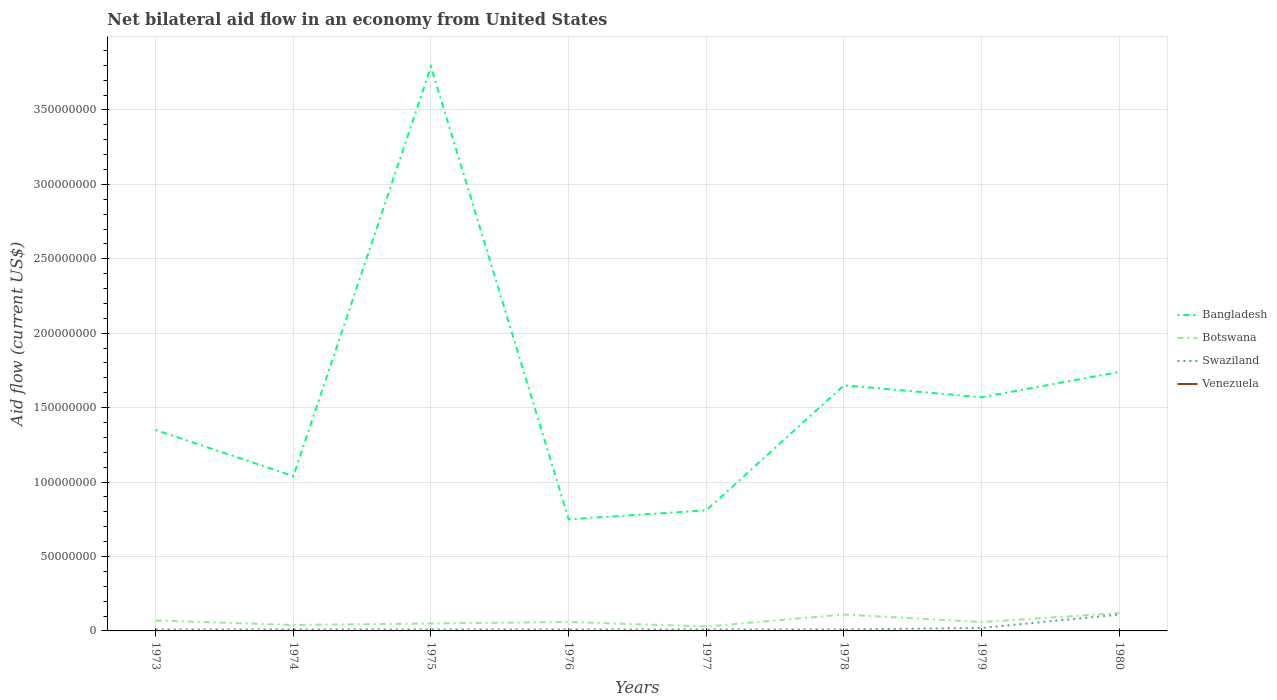How many different coloured lines are there?
Give a very brief answer. 3. Across all years, what is the maximum net bilateral aid flow in Bangladesh?
Your answer should be very brief. 7.50e+07. What is the total net bilateral aid flow in Bangladesh in the graph?
Offer a very short reply. 2.22e+08. What is the difference between the highest and the second highest net bilateral aid flow in Botswana?
Offer a terse response. 9.00e+06. How many years are there in the graph?
Offer a terse response. 8. What is the difference between two consecutive major ticks on the Y-axis?
Your answer should be very brief. 5.00e+07. Are the values on the major ticks of Y-axis written in scientific E-notation?
Your response must be concise. No. Where does the legend appear in the graph?
Your answer should be compact. Center right. How many legend labels are there?
Keep it short and to the point. 4. What is the title of the graph?
Give a very brief answer. Net bilateral aid flow in an economy from United States. What is the label or title of the X-axis?
Offer a very short reply. Years. What is the Aid flow (current US$) of Bangladesh in 1973?
Make the answer very short. 1.35e+08. What is the Aid flow (current US$) of Botswana in 1973?
Your response must be concise. 7.00e+06. What is the Aid flow (current US$) in Bangladesh in 1974?
Your response must be concise. 1.04e+08. What is the Aid flow (current US$) of Botswana in 1974?
Offer a very short reply. 4.00e+06. What is the Aid flow (current US$) of Bangladesh in 1975?
Your answer should be compact. 3.79e+08. What is the Aid flow (current US$) in Botswana in 1975?
Ensure brevity in your answer.  5.00e+06. What is the Aid flow (current US$) of Swaziland in 1975?
Your answer should be compact. 1.00e+06. What is the Aid flow (current US$) in Venezuela in 1975?
Ensure brevity in your answer.  0. What is the Aid flow (current US$) of Bangladesh in 1976?
Ensure brevity in your answer.  7.50e+07. What is the Aid flow (current US$) in Botswana in 1976?
Keep it short and to the point. 6.00e+06. What is the Aid flow (current US$) in Swaziland in 1976?
Your answer should be compact. 1.00e+06. What is the Aid flow (current US$) of Venezuela in 1976?
Provide a succinct answer. 0. What is the Aid flow (current US$) in Bangladesh in 1977?
Offer a very short reply. 8.10e+07. What is the Aid flow (current US$) in Swaziland in 1977?
Give a very brief answer. 1.00e+06. What is the Aid flow (current US$) in Venezuela in 1977?
Ensure brevity in your answer.  0. What is the Aid flow (current US$) of Bangladesh in 1978?
Ensure brevity in your answer.  1.65e+08. What is the Aid flow (current US$) of Botswana in 1978?
Provide a succinct answer. 1.10e+07. What is the Aid flow (current US$) in Bangladesh in 1979?
Your answer should be very brief. 1.57e+08. What is the Aid flow (current US$) in Swaziland in 1979?
Keep it short and to the point. 2.00e+06. What is the Aid flow (current US$) of Venezuela in 1979?
Ensure brevity in your answer.  0. What is the Aid flow (current US$) in Bangladesh in 1980?
Make the answer very short. 1.74e+08. What is the Aid flow (current US$) in Botswana in 1980?
Provide a succinct answer. 1.20e+07. What is the Aid flow (current US$) in Swaziland in 1980?
Provide a succinct answer. 1.10e+07. What is the Aid flow (current US$) in Venezuela in 1980?
Keep it short and to the point. 0. Across all years, what is the maximum Aid flow (current US$) in Bangladesh?
Your response must be concise. 3.79e+08. Across all years, what is the maximum Aid flow (current US$) in Swaziland?
Keep it short and to the point. 1.10e+07. Across all years, what is the minimum Aid flow (current US$) in Bangladesh?
Provide a short and direct response. 7.50e+07. Across all years, what is the minimum Aid flow (current US$) of Botswana?
Provide a short and direct response. 3.00e+06. What is the total Aid flow (current US$) in Bangladesh in the graph?
Offer a terse response. 1.27e+09. What is the total Aid flow (current US$) of Botswana in the graph?
Ensure brevity in your answer.  5.40e+07. What is the total Aid flow (current US$) in Swaziland in the graph?
Provide a succinct answer. 1.90e+07. What is the total Aid flow (current US$) in Venezuela in the graph?
Offer a very short reply. 0. What is the difference between the Aid flow (current US$) of Bangladesh in 1973 and that in 1974?
Your answer should be very brief. 3.10e+07. What is the difference between the Aid flow (current US$) of Swaziland in 1973 and that in 1974?
Ensure brevity in your answer.  0. What is the difference between the Aid flow (current US$) of Bangladesh in 1973 and that in 1975?
Give a very brief answer. -2.44e+08. What is the difference between the Aid flow (current US$) in Botswana in 1973 and that in 1975?
Offer a very short reply. 2.00e+06. What is the difference between the Aid flow (current US$) in Swaziland in 1973 and that in 1975?
Your answer should be very brief. 0. What is the difference between the Aid flow (current US$) in Bangladesh in 1973 and that in 1976?
Your response must be concise. 6.00e+07. What is the difference between the Aid flow (current US$) in Botswana in 1973 and that in 1976?
Offer a terse response. 1.00e+06. What is the difference between the Aid flow (current US$) of Swaziland in 1973 and that in 1976?
Provide a succinct answer. 0. What is the difference between the Aid flow (current US$) in Bangladesh in 1973 and that in 1977?
Keep it short and to the point. 5.40e+07. What is the difference between the Aid flow (current US$) of Botswana in 1973 and that in 1977?
Keep it short and to the point. 4.00e+06. What is the difference between the Aid flow (current US$) in Swaziland in 1973 and that in 1977?
Offer a very short reply. 0. What is the difference between the Aid flow (current US$) in Bangladesh in 1973 and that in 1978?
Offer a very short reply. -3.00e+07. What is the difference between the Aid flow (current US$) in Botswana in 1973 and that in 1978?
Your response must be concise. -4.00e+06. What is the difference between the Aid flow (current US$) in Swaziland in 1973 and that in 1978?
Ensure brevity in your answer.  0. What is the difference between the Aid flow (current US$) of Bangladesh in 1973 and that in 1979?
Keep it short and to the point. -2.20e+07. What is the difference between the Aid flow (current US$) in Bangladesh in 1973 and that in 1980?
Give a very brief answer. -3.90e+07. What is the difference between the Aid flow (current US$) in Botswana in 1973 and that in 1980?
Provide a succinct answer. -5.00e+06. What is the difference between the Aid flow (current US$) in Swaziland in 1973 and that in 1980?
Ensure brevity in your answer.  -1.00e+07. What is the difference between the Aid flow (current US$) of Bangladesh in 1974 and that in 1975?
Your answer should be very brief. -2.75e+08. What is the difference between the Aid flow (current US$) in Botswana in 1974 and that in 1975?
Your response must be concise. -1.00e+06. What is the difference between the Aid flow (current US$) of Swaziland in 1974 and that in 1975?
Offer a terse response. 0. What is the difference between the Aid flow (current US$) in Bangladesh in 1974 and that in 1976?
Make the answer very short. 2.90e+07. What is the difference between the Aid flow (current US$) in Botswana in 1974 and that in 1976?
Keep it short and to the point. -2.00e+06. What is the difference between the Aid flow (current US$) of Swaziland in 1974 and that in 1976?
Offer a very short reply. 0. What is the difference between the Aid flow (current US$) of Bangladesh in 1974 and that in 1977?
Your answer should be very brief. 2.30e+07. What is the difference between the Aid flow (current US$) in Swaziland in 1974 and that in 1977?
Keep it short and to the point. 0. What is the difference between the Aid flow (current US$) in Bangladesh in 1974 and that in 1978?
Offer a very short reply. -6.10e+07. What is the difference between the Aid flow (current US$) in Botswana in 1974 and that in 1978?
Your answer should be compact. -7.00e+06. What is the difference between the Aid flow (current US$) of Swaziland in 1974 and that in 1978?
Make the answer very short. 0. What is the difference between the Aid flow (current US$) in Bangladesh in 1974 and that in 1979?
Offer a very short reply. -5.30e+07. What is the difference between the Aid flow (current US$) in Botswana in 1974 and that in 1979?
Offer a terse response. -2.00e+06. What is the difference between the Aid flow (current US$) of Swaziland in 1974 and that in 1979?
Provide a succinct answer. -1.00e+06. What is the difference between the Aid flow (current US$) in Bangladesh in 1974 and that in 1980?
Offer a terse response. -7.00e+07. What is the difference between the Aid flow (current US$) in Botswana in 1974 and that in 1980?
Ensure brevity in your answer.  -8.00e+06. What is the difference between the Aid flow (current US$) of Swaziland in 1974 and that in 1980?
Offer a terse response. -1.00e+07. What is the difference between the Aid flow (current US$) of Bangladesh in 1975 and that in 1976?
Ensure brevity in your answer.  3.04e+08. What is the difference between the Aid flow (current US$) of Swaziland in 1975 and that in 1976?
Your answer should be compact. 0. What is the difference between the Aid flow (current US$) in Bangladesh in 1975 and that in 1977?
Offer a terse response. 2.98e+08. What is the difference between the Aid flow (current US$) of Botswana in 1975 and that in 1977?
Ensure brevity in your answer.  2.00e+06. What is the difference between the Aid flow (current US$) in Bangladesh in 1975 and that in 1978?
Provide a short and direct response. 2.14e+08. What is the difference between the Aid flow (current US$) in Botswana in 1975 and that in 1978?
Your response must be concise. -6.00e+06. What is the difference between the Aid flow (current US$) of Swaziland in 1975 and that in 1978?
Your response must be concise. 0. What is the difference between the Aid flow (current US$) of Bangladesh in 1975 and that in 1979?
Ensure brevity in your answer.  2.22e+08. What is the difference between the Aid flow (current US$) in Botswana in 1975 and that in 1979?
Provide a succinct answer. -1.00e+06. What is the difference between the Aid flow (current US$) of Bangladesh in 1975 and that in 1980?
Offer a terse response. 2.05e+08. What is the difference between the Aid flow (current US$) of Botswana in 1975 and that in 1980?
Give a very brief answer. -7.00e+06. What is the difference between the Aid flow (current US$) of Swaziland in 1975 and that in 1980?
Your answer should be very brief. -1.00e+07. What is the difference between the Aid flow (current US$) in Bangladesh in 1976 and that in 1977?
Give a very brief answer. -6.00e+06. What is the difference between the Aid flow (current US$) of Botswana in 1976 and that in 1977?
Your response must be concise. 3.00e+06. What is the difference between the Aid flow (current US$) in Bangladesh in 1976 and that in 1978?
Give a very brief answer. -9.00e+07. What is the difference between the Aid flow (current US$) of Botswana in 1976 and that in 1978?
Provide a short and direct response. -5.00e+06. What is the difference between the Aid flow (current US$) of Swaziland in 1976 and that in 1978?
Your answer should be very brief. 0. What is the difference between the Aid flow (current US$) of Bangladesh in 1976 and that in 1979?
Ensure brevity in your answer.  -8.20e+07. What is the difference between the Aid flow (current US$) of Bangladesh in 1976 and that in 1980?
Give a very brief answer. -9.90e+07. What is the difference between the Aid flow (current US$) of Botswana in 1976 and that in 1980?
Offer a terse response. -6.00e+06. What is the difference between the Aid flow (current US$) in Swaziland in 1976 and that in 1980?
Make the answer very short. -1.00e+07. What is the difference between the Aid flow (current US$) in Bangladesh in 1977 and that in 1978?
Give a very brief answer. -8.40e+07. What is the difference between the Aid flow (current US$) of Botswana in 1977 and that in 1978?
Keep it short and to the point. -8.00e+06. What is the difference between the Aid flow (current US$) of Bangladesh in 1977 and that in 1979?
Offer a terse response. -7.60e+07. What is the difference between the Aid flow (current US$) in Swaziland in 1977 and that in 1979?
Offer a very short reply. -1.00e+06. What is the difference between the Aid flow (current US$) in Bangladesh in 1977 and that in 1980?
Provide a succinct answer. -9.30e+07. What is the difference between the Aid flow (current US$) of Botswana in 1977 and that in 1980?
Make the answer very short. -9.00e+06. What is the difference between the Aid flow (current US$) in Swaziland in 1977 and that in 1980?
Your response must be concise. -1.00e+07. What is the difference between the Aid flow (current US$) of Bangladesh in 1978 and that in 1979?
Make the answer very short. 8.00e+06. What is the difference between the Aid flow (current US$) of Swaziland in 1978 and that in 1979?
Offer a very short reply. -1.00e+06. What is the difference between the Aid flow (current US$) of Bangladesh in 1978 and that in 1980?
Provide a short and direct response. -9.00e+06. What is the difference between the Aid flow (current US$) of Swaziland in 1978 and that in 1980?
Offer a terse response. -1.00e+07. What is the difference between the Aid flow (current US$) of Bangladesh in 1979 and that in 1980?
Ensure brevity in your answer.  -1.70e+07. What is the difference between the Aid flow (current US$) in Botswana in 1979 and that in 1980?
Offer a very short reply. -6.00e+06. What is the difference between the Aid flow (current US$) in Swaziland in 1979 and that in 1980?
Give a very brief answer. -9.00e+06. What is the difference between the Aid flow (current US$) in Bangladesh in 1973 and the Aid flow (current US$) in Botswana in 1974?
Provide a short and direct response. 1.31e+08. What is the difference between the Aid flow (current US$) in Bangladesh in 1973 and the Aid flow (current US$) in Swaziland in 1974?
Provide a succinct answer. 1.34e+08. What is the difference between the Aid flow (current US$) in Botswana in 1973 and the Aid flow (current US$) in Swaziland in 1974?
Provide a short and direct response. 6.00e+06. What is the difference between the Aid flow (current US$) of Bangladesh in 1973 and the Aid flow (current US$) of Botswana in 1975?
Make the answer very short. 1.30e+08. What is the difference between the Aid flow (current US$) of Bangladesh in 1973 and the Aid flow (current US$) of Swaziland in 1975?
Your answer should be very brief. 1.34e+08. What is the difference between the Aid flow (current US$) of Botswana in 1973 and the Aid flow (current US$) of Swaziland in 1975?
Offer a very short reply. 6.00e+06. What is the difference between the Aid flow (current US$) of Bangladesh in 1973 and the Aid flow (current US$) of Botswana in 1976?
Give a very brief answer. 1.29e+08. What is the difference between the Aid flow (current US$) of Bangladesh in 1973 and the Aid flow (current US$) of Swaziland in 1976?
Offer a terse response. 1.34e+08. What is the difference between the Aid flow (current US$) of Botswana in 1973 and the Aid flow (current US$) of Swaziland in 1976?
Provide a succinct answer. 6.00e+06. What is the difference between the Aid flow (current US$) in Bangladesh in 1973 and the Aid flow (current US$) in Botswana in 1977?
Offer a terse response. 1.32e+08. What is the difference between the Aid flow (current US$) of Bangladesh in 1973 and the Aid flow (current US$) of Swaziland in 1977?
Provide a succinct answer. 1.34e+08. What is the difference between the Aid flow (current US$) in Bangladesh in 1973 and the Aid flow (current US$) in Botswana in 1978?
Give a very brief answer. 1.24e+08. What is the difference between the Aid flow (current US$) in Bangladesh in 1973 and the Aid flow (current US$) in Swaziland in 1978?
Provide a short and direct response. 1.34e+08. What is the difference between the Aid flow (current US$) of Bangladesh in 1973 and the Aid flow (current US$) of Botswana in 1979?
Your response must be concise. 1.29e+08. What is the difference between the Aid flow (current US$) in Bangladesh in 1973 and the Aid flow (current US$) in Swaziland in 1979?
Offer a terse response. 1.33e+08. What is the difference between the Aid flow (current US$) in Botswana in 1973 and the Aid flow (current US$) in Swaziland in 1979?
Give a very brief answer. 5.00e+06. What is the difference between the Aid flow (current US$) of Bangladesh in 1973 and the Aid flow (current US$) of Botswana in 1980?
Your answer should be compact. 1.23e+08. What is the difference between the Aid flow (current US$) of Bangladesh in 1973 and the Aid flow (current US$) of Swaziland in 1980?
Your response must be concise. 1.24e+08. What is the difference between the Aid flow (current US$) of Botswana in 1973 and the Aid flow (current US$) of Swaziland in 1980?
Offer a terse response. -4.00e+06. What is the difference between the Aid flow (current US$) in Bangladesh in 1974 and the Aid flow (current US$) in Botswana in 1975?
Give a very brief answer. 9.90e+07. What is the difference between the Aid flow (current US$) in Bangladesh in 1974 and the Aid flow (current US$) in Swaziland in 1975?
Your answer should be compact. 1.03e+08. What is the difference between the Aid flow (current US$) of Botswana in 1974 and the Aid flow (current US$) of Swaziland in 1975?
Give a very brief answer. 3.00e+06. What is the difference between the Aid flow (current US$) of Bangladesh in 1974 and the Aid flow (current US$) of Botswana in 1976?
Keep it short and to the point. 9.80e+07. What is the difference between the Aid flow (current US$) in Bangladesh in 1974 and the Aid flow (current US$) in Swaziland in 1976?
Provide a succinct answer. 1.03e+08. What is the difference between the Aid flow (current US$) of Botswana in 1974 and the Aid flow (current US$) of Swaziland in 1976?
Provide a short and direct response. 3.00e+06. What is the difference between the Aid flow (current US$) of Bangladesh in 1974 and the Aid flow (current US$) of Botswana in 1977?
Give a very brief answer. 1.01e+08. What is the difference between the Aid flow (current US$) of Bangladesh in 1974 and the Aid flow (current US$) of Swaziland in 1977?
Offer a very short reply. 1.03e+08. What is the difference between the Aid flow (current US$) in Bangladesh in 1974 and the Aid flow (current US$) in Botswana in 1978?
Your answer should be very brief. 9.30e+07. What is the difference between the Aid flow (current US$) of Bangladesh in 1974 and the Aid flow (current US$) of Swaziland in 1978?
Your answer should be compact. 1.03e+08. What is the difference between the Aid flow (current US$) in Bangladesh in 1974 and the Aid flow (current US$) in Botswana in 1979?
Offer a terse response. 9.80e+07. What is the difference between the Aid flow (current US$) of Bangladesh in 1974 and the Aid flow (current US$) of Swaziland in 1979?
Your answer should be very brief. 1.02e+08. What is the difference between the Aid flow (current US$) in Bangladesh in 1974 and the Aid flow (current US$) in Botswana in 1980?
Keep it short and to the point. 9.20e+07. What is the difference between the Aid flow (current US$) of Bangladesh in 1974 and the Aid flow (current US$) of Swaziland in 1980?
Ensure brevity in your answer.  9.30e+07. What is the difference between the Aid flow (current US$) in Botswana in 1974 and the Aid flow (current US$) in Swaziland in 1980?
Give a very brief answer. -7.00e+06. What is the difference between the Aid flow (current US$) in Bangladesh in 1975 and the Aid flow (current US$) in Botswana in 1976?
Offer a terse response. 3.73e+08. What is the difference between the Aid flow (current US$) in Bangladesh in 1975 and the Aid flow (current US$) in Swaziland in 1976?
Keep it short and to the point. 3.78e+08. What is the difference between the Aid flow (current US$) in Botswana in 1975 and the Aid flow (current US$) in Swaziland in 1976?
Provide a succinct answer. 4.00e+06. What is the difference between the Aid flow (current US$) of Bangladesh in 1975 and the Aid flow (current US$) of Botswana in 1977?
Keep it short and to the point. 3.76e+08. What is the difference between the Aid flow (current US$) in Bangladesh in 1975 and the Aid flow (current US$) in Swaziland in 1977?
Make the answer very short. 3.78e+08. What is the difference between the Aid flow (current US$) in Botswana in 1975 and the Aid flow (current US$) in Swaziland in 1977?
Provide a succinct answer. 4.00e+06. What is the difference between the Aid flow (current US$) in Bangladesh in 1975 and the Aid flow (current US$) in Botswana in 1978?
Ensure brevity in your answer.  3.68e+08. What is the difference between the Aid flow (current US$) of Bangladesh in 1975 and the Aid flow (current US$) of Swaziland in 1978?
Ensure brevity in your answer.  3.78e+08. What is the difference between the Aid flow (current US$) in Botswana in 1975 and the Aid flow (current US$) in Swaziland in 1978?
Make the answer very short. 4.00e+06. What is the difference between the Aid flow (current US$) of Bangladesh in 1975 and the Aid flow (current US$) of Botswana in 1979?
Make the answer very short. 3.73e+08. What is the difference between the Aid flow (current US$) in Bangladesh in 1975 and the Aid flow (current US$) in Swaziland in 1979?
Offer a terse response. 3.77e+08. What is the difference between the Aid flow (current US$) in Botswana in 1975 and the Aid flow (current US$) in Swaziland in 1979?
Offer a terse response. 3.00e+06. What is the difference between the Aid flow (current US$) in Bangladesh in 1975 and the Aid flow (current US$) in Botswana in 1980?
Your answer should be compact. 3.67e+08. What is the difference between the Aid flow (current US$) in Bangladesh in 1975 and the Aid flow (current US$) in Swaziland in 1980?
Your answer should be compact. 3.68e+08. What is the difference between the Aid flow (current US$) of Botswana in 1975 and the Aid flow (current US$) of Swaziland in 1980?
Your response must be concise. -6.00e+06. What is the difference between the Aid flow (current US$) of Bangladesh in 1976 and the Aid flow (current US$) of Botswana in 1977?
Provide a succinct answer. 7.20e+07. What is the difference between the Aid flow (current US$) of Bangladesh in 1976 and the Aid flow (current US$) of Swaziland in 1977?
Make the answer very short. 7.40e+07. What is the difference between the Aid flow (current US$) of Botswana in 1976 and the Aid flow (current US$) of Swaziland in 1977?
Your answer should be compact. 5.00e+06. What is the difference between the Aid flow (current US$) in Bangladesh in 1976 and the Aid flow (current US$) in Botswana in 1978?
Give a very brief answer. 6.40e+07. What is the difference between the Aid flow (current US$) in Bangladesh in 1976 and the Aid flow (current US$) in Swaziland in 1978?
Give a very brief answer. 7.40e+07. What is the difference between the Aid flow (current US$) in Botswana in 1976 and the Aid flow (current US$) in Swaziland in 1978?
Your answer should be very brief. 5.00e+06. What is the difference between the Aid flow (current US$) in Bangladesh in 1976 and the Aid flow (current US$) in Botswana in 1979?
Make the answer very short. 6.90e+07. What is the difference between the Aid flow (current US$) of Bangladesh in 1976 and the Aid flow (current US$) of Swaziland in 1979?
Give a very brief answer. 7.30e+07. What is the difference between the Aid flow (current US$) in Botswana in 1976 and the Aid flow (current US$) in Swaziland in 1979?
Offer a terse response. 4.00e+06. What is the difference between the Aid flow (current US$) in Bangladesh in 1976 and the Aid flow (current US$) in Botswana in 1980?
Offer a terse response. 6.30e+07. What is the difference between the Aid flow (current US$) of Bangladesh in 1976 and the Aid flow (current US$) of Swaziland in 1980?
Your response must be concise. 6.40e+07. What is the difference between the Aid flow (current US$) in Botswana in 1976 and the Aid flow (current US$) in Swaziland in 1980?
Your answer should be compact. -5.00e+06. What is the difference between the Aid flow (current US$) in Bangladesh in 1977 and the Aid flow (current US$) in Botswana in 1978?
Make the answer very short. 7.00e+07. What is the difference between the Aid flow (current US$) of Bangladesh in 1977 and the Aid flow (current US$) of Swaziland in 1978?
Keep it short and to the point. 8.00e+07. What is the difference between the Aid flow (current US$) in Bangladesh in 1977 and the Aid flow (current US$) in Botswana in 1979?
Your answer should be very brief. 7.50e+07. What is the difference between the Aid flow (current US$) of Bangladesh in 1977 and the Aid flow (current US$) of Swaziland in 1979?
Ensure brevity in your answer.  7.90e+07. What is the difference between the Aid flow (current US$) in Botswana in 1977 and the Aid flow (current US$) in Swaziland in 1979?
Provide a short and direct response. 1.00e+06. What is the difference between the Aid flow (current US$) of Bangladesh in 1977 and the Aid flow (current US$) of Botswana in 1980?
Make the answer very short. 6.90e+07. What is the difference between the Aid flow (current US$) in Bangladesh in 1977 and the Aid flow (current US$) in Swaziland in 1980?
Keep it short and to the point. 7.00e+07. What is the difference between the Aid flow (current US$) in Botswana in 1977 and the Aid flow (current US$) in Swaziland in 1980?
Your answer should be compact. -8.00e+06. What is the difference between the Aid flow (current US$) of Bangladesh in 1978 and the Aid flow (current US$) of Botswana in 1979?
Your answer should be compact. 1.59e+08. What is the difference between the Aid flow (current US$) of Bangladesh in 1978 and the Aid flow (current US$) of Swaziland in 1979?
Offer a terse response. 1.63e+08. What is the difference between the Aid flow (current US$) of Botswana in 1978 and the Aid flow (current US$) of Swaziland in 1979?
Your response must be concise. 9.00e+06. What is the difference between the Aid flow (current US$) of Bangladesh in 1978 and the Aid flow (current US$) of Botswana in 1980?
Keep it short and to the point. 1.53e+08. What is the difference between the Aid flow (current US$) in Bangladesh in 1978 and the Aid flow (current US$) in Swaziland in 1980?
Give a very brief answer. 1.54e+08. What is the difference between the Aid flow (current US$) of Bangladesh in 1979 and the Aid flow (current US$) of Botswana in 1980?
Your answer should be very brief. 1.45e+08. What is the difference between the Aid flow (current US$) in Bangladesh in 1979 and the Aid flow (current US$) in Swaziland in 1980?
Keep it short and to the point. 1.46e+08. What is the difference between the Aid flow (current US$) in Botswana in 1979 and the Aid flow (current US$) in Swaziland in 1980?
Ensure brevity in your answer.  -5.00e+06. What is the average Aid flow (current US$) of Bangladesh per year?
Offer a very short reply. 1.59e+08. What is the average Aid flow (current US$) in Botswana per year?
Keep it short and to the point. 6.75e+06. What is the average Aid flow (current US$) of Swaziland per year?
Your answer should be compact. 2.38e+06. What is the average Aid flow (current US$) in Venezuela per year?
Provide a succinct answer. 0. In the year 1973, what is the difference between the Aid flow (current US$) of Bangladesh and Aid flow (current US$) of Botswana?
Give a very brief answer. 1.28e+08. In the year 1973, what is the difference between the Aid flow (current US$) in Bangladesh and Aid flow (current US$) in Swaziland?
Your answer should be compact. 1.34e+08. In the year 1974, what is the difference between the Aid flow (current US$) in Bangladesh and Aid flow (current US$) in Botswana?
Your answer should be compact. 1.00e+08. In the year 1974, what is the difference between the Aid flow (current US$) in Bangladesh and Aid flow (current US$) in Swaziland?
Offer a terse response. 1.03e+08. In the year 1974, what is the difference between the Aid flow (current US$) in Botswana and Aid flow (current US$) in Swaziland?
Provide a succinct answer. 3.00e+06. In the year 1975, what is the difference between the Aid flow (current US$) of Bangladesh and Aid flow (current US$) of Botswana?
Your response must be concise. 3.74e+08. In the year 1975, what is the difference between the Aid flow (current US$) in Bangladesh and Aid flow (current US$) in Swaziland?
Provide a succinct answer. 3.78e+08. In the year 1976, what is the difference between the Aid flow (current US$) in Bangladesh and Aid flow (current US$) in Botswana?
Make the answer very short. 6.90e+07. In the year 1976, what is the difference between the Aid flow (current US$) in Bangladesh and Aid flow (current US$) in Swaziland?
Make the answer very short. 7.40e+07. In the year 1976, what is the difference between the Aid flow (current US$) in Botswana and Aid flow (current US$) in Swaziland?
Provide a short and direct response. 5.00e+06. In the year 1977, what is the difference between the Aid flow (current US$) in Bangladesh and Aid flow (current US$) in Botswana?
Your answer should be compact. 7.80e+07. In the year 1977, what is the difference between the Aid flow (current US$) in Bangladesh and Aid flow (current US$) in Swaziland?
Your answer should be compact. 8.00e+07. In the year 1977, what is the difference between the Aid flow (current US$) of Botswana and Aid flow (current US$) of Swaziland?
Ensure brevity in your answer.  2.00e+06. In the year 1978, what is the difference between the Aid flow (current US$) in Bangladesh and Aid flow (current US$) in Botswana?
Offer a terse response. 1.54e+08. In the year 1978, what is the difference between the Aid flow (current US$) of Bangladesh and Aid flow (current US$) of Swaziland?
Your answer should be compact. 1.64e+08. In the year 1978, what is the difference between the Aid flow (current US$) of Botswana and Aid flow (current US$) of Swaziland?
Provide a succinct answer. 1.00e+07. In the year 1979, what is the difference between the Aid flow (current US$) in Bangladesh and Aid flow (current US$) in Botswana?
Provide a short and direct response. 1.51e+08. In the year 1979, what is the difference between the Aid flow (current US$) of Bangladesh and Aid flow (current US$) of Swaziland?
Give a very brief answer. 1.55e+08. In the year 1980, what is the difference between the Aid flow (current US$) of Bangladesh and Aid flow (current US$) of Botswana?
Offer a terse response. 1.62e+08. In the year 1980, what is the difference between the Aid flow (current US$) in Bangladesh and Aid flow (current US$) in Swaziland?
Offer a very short reply. 1.63e+08. What is the ratio of the Aid flow (current US$) of Bangladesh in 1973 to that in 1974?
Your answer should be compact. 1.3. What is the ratio of the Aid flow (current US$) of Swaziland in 1973 to that in 1974?
Your response must be concise. 1. What is the ratio of the Aid flow (current US$) in Bangladesh in 1973 to that in 1975?
Give a very brief answer. 0.36. What is the ratio of the Aid flow (current US$) of Botswana in 1973 to that in 1975?
Your answer should be very brief. 1.4. What is the ratio of the Aid flow (current US$) in Bangladesh in 1973 to that in 1976?
Your response must be concise. 1.8. What is the ratio of the Aid flow (current US$) of Botswana in 1973 to that in 1976?
Offer a terse response. 1.17. What is the ratio of the Aid flow (current US$) in Swaziland in 1973 to that in 1976?
Offer a very short reply. 1. What is the ratio of the Aid flow (current US$) of Botswana in 1973 to that in 1977?
Provide a short and direct response. 2.33. What is the ratio of the Aid flow (current US$) of Bangladesh in 1973 to that in 1978?
Offer a terse response. 0.82. What is the ratio of the Aid flow (current US$) of Botswana in 1973 to that in 1978?
Your answer should be very brief. 0.64. What is the ratio of the Aid flow (current US$) of Bangladesh in 1973 to that in 1979?
Give a very brief answer. 0.86. What is the ratio of the Aid flow (current US$) of Bangladesh in 1973 to that in 1980?
Offer a terse response. 0.78. What is the ratio of the Aid flow (current US$) in Botswana in 1973 to that in 1980?
Provide a short and direct response. 0.58. What is the ratio of the Aid flow (current US$) in Swaziland in 1973 to that in 1980?
Give a very brief answer. 0.09. What is the ratio of the Aid flow (current US$) of Bangladesh in 1974 to that in 1975?
Your answer should be compact. 0.27. What is the ratio of the Aid flow (current US$) in Botswana in 1974 to that in 1975?
Make the answer very short. 0.8. What is the ratio of the Aid flow (current US$) of Swaziland in 1974 to that in 1975?
Offer a very short reply. 1. What is the ratio of the Aid flow (current US$) of Bangladesh in 1974 to that in 1976?
Your answer should be very brief. 1.39. What is the ratio of the Aid flow (current US$) in Bangladesh in 1974 to that in 1977?
Your answer should be compact. 1.28. What is the ratio of the Aid flow (current US$) of Botswana in 1974 to that in 1977?
Offer a terse response. 1.33. What is the ratio of the Aid flow (current US$) in Swaziland in 1974 to that in 1977?
Your answer should be compact. 1. What is the ratio of the Aid flow (current US$) in Bangladesh in 1974 to that in 1978?
Offer a terse response. 0.63. What is the ratio of the Aid flow (current US$) of Botswana in 1974 to that in 1978?
Your response must be concise. 0.36. What is the ratio of the Aid flow (current US$) in Bangladesh in 1974 to that in 1979?
Keep it short and to the point. 0.66. What is the ratio of the Aid flow (current US$) in Botswana in 1974 to that in 1979?
Keep it short and to the point. 0.67. What is the ratio of the Aid flow (current US$) in Swaziland in 1974 to that in 1979?
Offer a terse response. 0.5. What is the ratio of the Aid flow (current US$) of Bangladesh in 1974 to that in 1980?
Offer a terse response. 0.6. What is the ratio of the Aid flow (current US$) of Swaziland in 1974 to that in 1980?
Make the answer very short. 0.09. What is the ratio of the Aid flow (current US$) in Bangladesh in 1975 to that in 1976?
Your response must be concise. 5.05. What is the ratio of the Aid flow (current US$) in Botswana in 1975 to that in 1976?
Ensure brevity in your answer.  0.83. What is the ratio of the Aid flow (current US$) of Swaziland in 1975 to that in 1976?
Offer a very short reply. 1. What is the ratio of the Aid flow (current US$) of Bangladesh in 1975 to that in 1977?
Your response must be concise. 4.68. What is the ratio of the Aid flow (current US$) in Botswana in 1975 to that in 1977?
Keep it short and to the point. 1.67. What is the ratio of the Aid flow (current US$) in Bangladesh in 1975 to that in 1978?
Your answer should be very brief. 2.3. What is the ratio of the Aid flow (current US$) in Botswana in 1975 to that in 1978?
Your answer should be compact. 0.45. What is the ratio of the Aid flow (current US$) of Bangladesh in 1975 to that in 1979?
Provide a short and direct response. 2.41. What is the ratio of the Aid flow (current US$) of Swaziland in 1975 to that in 1979?
Provide a short and direct response. 0.5. What is the ratio of the Aid flow (current US$) of Bangladesh in 1975 to that in 1980?
Your answer should be compact. 2.18. What is the ratio of the Aid flow (current US$) in Botswana in 1975 to that in 1980?
Offer a very short reply. 0.42. What is the ratio of the Aid flow (current US$) in Swaziland in 1975 to that in 1980?
Offer a very short reply. 0.09. What is the ratio of the Aid flow (current US$) of Bangladesh in 1976 to that in 1977?
Offer a terse response. 0.93. What is the ratio of the Aid flow (current US$) of Swaziland in 1976 to that in 1977?
Give a very brief answer. 1. What is the ratio of the Aid flow (current US$) in Bangladesh in 1976 to that in 1978?
Provide a short and direct response. 0.45. What is the ratio of the Aid flow (current US$) of Botswana in 1976 to that in 1978?
Give a very brief answer. 0.55. What is the ratio of the Aid flow (current US$) in Bangladesh in 1976 to that in 1979?
Your response must be concise. 0.48. What is the ratio of the Aid flow (current US$) in Botswana in 1976 to that in 1979?
Keep it short and to the point. 1. What is the ratio of the Aid flow (current US$) of Bangladesh in 1976 to that in 1980?
Your answer should be very brief. 0.43. What is the ratio of the Aid flow (current US$) of Swaziland in 1976 to that in 1980?
Offer a terse response. 0.09. What is the ratio of the Aid flow (current US$) of Bangladesh in 1977 to that in 1978?
Your answer should be compact. 0.49. What is the ratio of the Aid flow (current US$) of Botswana in 1977 to that in 1978?
Make the answer very short. 0.27. What is the ratio of the Aid flow (current US$) of Bangladesh in 1977 to that in 1979?
Your response must be concise. 0.52. What is the ratio of the Aid flow (current US$) in Swaziland in 1977 to that in 1979?
Your answer should be compact. 0.5. What is the ratio of the Aid flow (current US$) of Bangladesh in 1977 to that in 1980?
Offer a very short reply. 0.47. What is the ratio of the Aid flow (current US$) of Botswana in 1977 to that in 1980?
Keep it short and to the point. 0.25. What is the ratio of the Aid flow (current US$) in Swaziland in 1977 to that in 1980?
Provide a short and direct response. 0.09. What is the ratio of the Aid flow (current US$) of Bangladesh in 1978 to that in 1979?
Your response must be concise. 1.05. What is the ratio of the Aid flow (current US$) in Botswana in 1978 to that in 1979?
Provide a succinct answer. 1.83. What is the ratio of the Aid flow (current US$) of Swaziland in 1978 to that in 1979?
Your answer should be very brief. 0.5. What is the ratio of the Aid flow (current US$) of Bangladesh in 1978 to that in 1980?
Offer a terse response. 0.95. What is the ratio of the Aid flow (current US$) in Botswana in 1978 to that in 1980?
Keep it short and to the point. 0.92. What is the ratio of the Aid flow (current US$) in Swaziland in 1978 to that in 1980?
Make the answer very short. 0.09. What is the ratio of the Aid flow (current US$) of Bangladesh in 1979 to that in 1980?
Your answer should be very brief. 0.9. What is the ratio of the Aid flow (current US$) of Swaziland in 1979 to that in 1980?
Provide a short and direct response. 0.18. What is the difference between the highest and the second highest Aid flow (current US$) of Bangladesh?
Your answer should be very brief. 2.05e+08. What is the difference between the highest and the second highest Aid flow (current US$) of Botswana?
Your response must be concise. 1.00e+06. What is the difference between the highest and the second highest Aid flow (current US$) in Swaziland?
Keep it short and to the point. 9.00e+06. What is the difference between the highest and the lowest Aid flow (current US$) of Bangladesh?
Offer a very short reply. 3.04e+08. What is the difference between the highest and the lowest Aid flow (current US$) of Botswana?
Your answer should be compact. 9.00e+06. What is the difference between the highest and the lowest Aid flow (current US$) in Swaziland?
Your answer should be compact. 1.00e+07. 